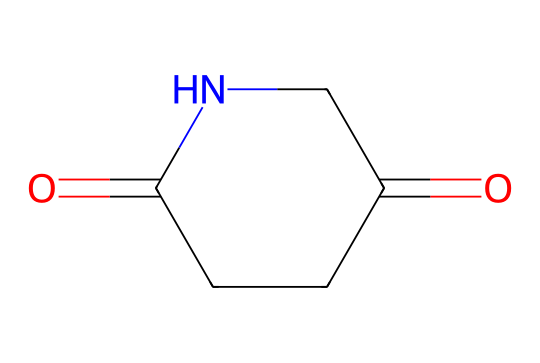What is the molecular formula of glutarimide? The SMILES representation of glutarimide, O=C1CCC(=O)NC1, can be translated to identify all atoms present. It contains 5 carbon (C) atoms, 7 hydrogen (H) atoms, 2 oxygen (O) atoms, and 1 nitrogen (N) atom. Therefore, the molecular formula is C5H7N2O2.
Answer: C5H7N2O2 How many rings are present in glutarimide? Analyzing the SMILES representation, the 'C1' indicates the start of a ring structure which closes back on itself at 'C1'. This means there is one ring present in glutarimide.
Answer: 1 What type of functional groups are present in glutarimide? By examining the structure given in the SMILES, glutarimide features a carbonyl group (C=O) and an amine group (NH). These functional groups are indicative of imides.
Answer: carbonyl and amine How many double bonds are present in glutarimide? The SMILES representation has two occurrences of '=' indicating double bonds; one in the carbonyl functional group and one between the carbon and nitrogen. Thus, glutarimide has two double bonds.
Answer: 2 Is glutarimide classified as a saturated or unsaturated compound? Saturated compounds have no double bonds, while unsaturated ones contain at least one. Since glutarimide has double bonds, it is classified as unsaturated.
Answer: unsaturated Which atoms are involved in the ring formation of glutarimide? The ring in glutarimide is formed by 5 carbon atoms and one nitrogen atom as seen in the SMILES representation where the numbering allows identification of the cyclic structure.
Answer: 5 carbons and 1 nitrogen Does glutarimide exhibit basic or acidic properties? Based on the presence of the nitrogen atom within an imide, which can accept protons, glutarimide exhibits basic properties in solution.
Answer: basic 